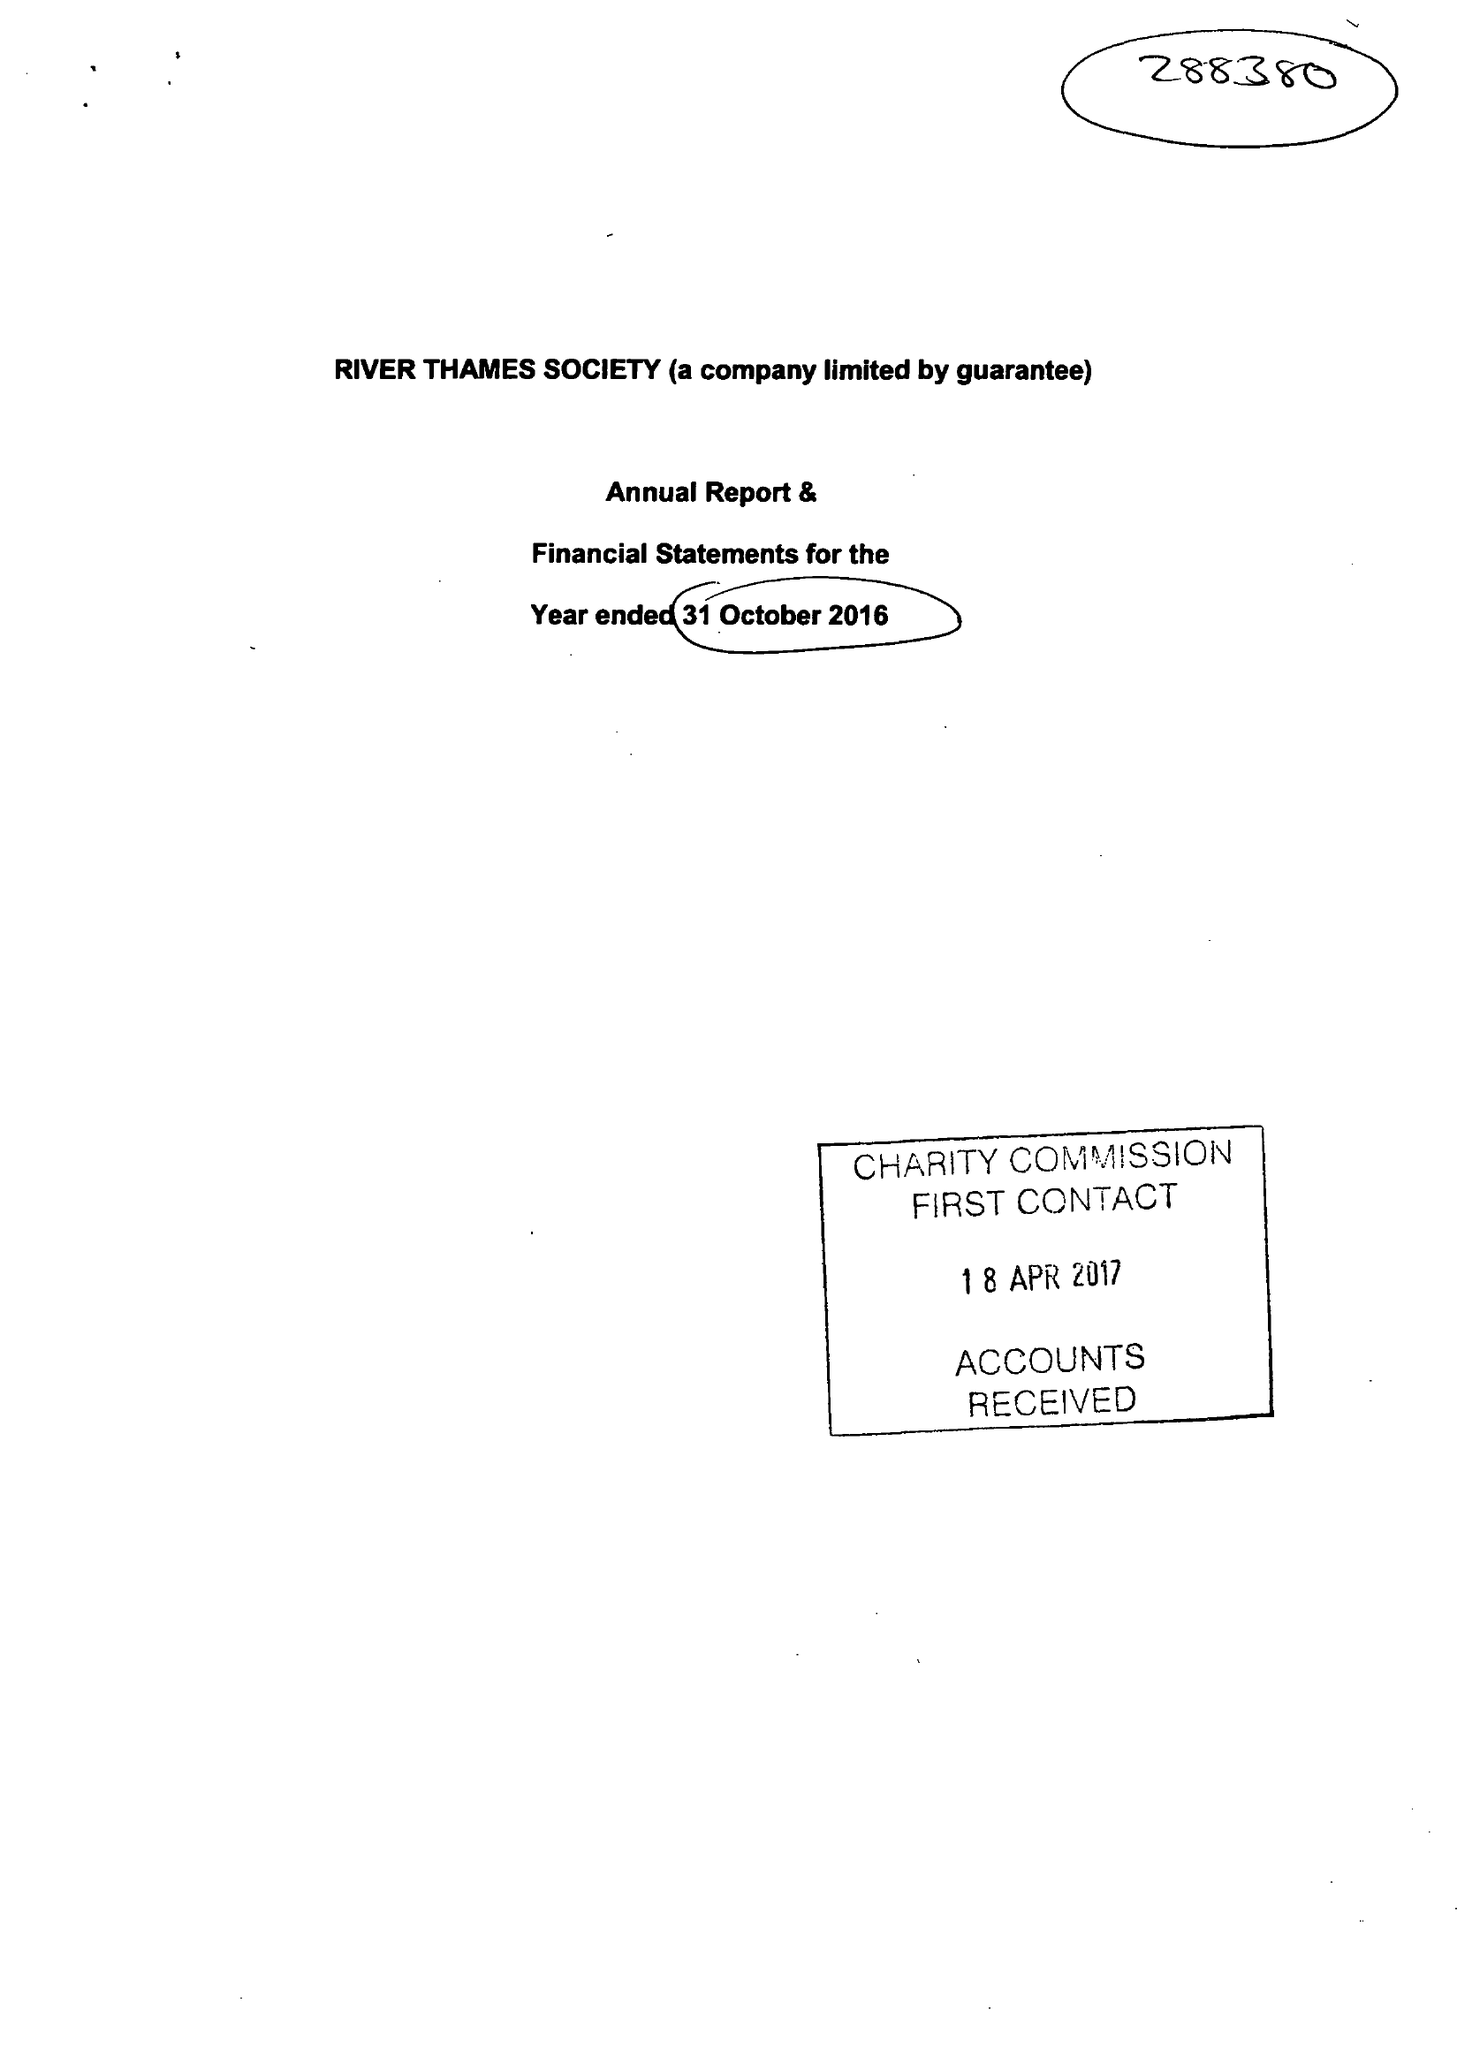What is the value for the address__post_town?
Answer the question using a single word or phrase. WINDSOR 